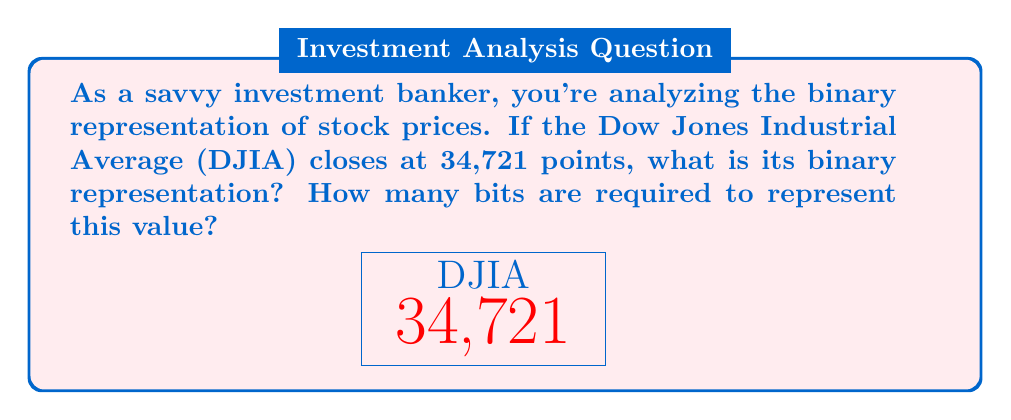Give your solution to this math problem. Let's approach this step-by-step:

1) To convert decimal to binary, we divide the number by 2 repeatedly and keep track of the remainders. The remainders in reverse order form the binary number.

   $34721 \div 2 = 17360$ remainder $1$
   $17360 \div 2 = 8680$  remainder $0$
   $8680 \div 2 = 4340$   remainder $0$
   $4340 \div 2 = 2170$   remainder $0$
   $2170 \div 2 = 1085$   remainder $0$
   $1085 \div 2 = 542$    remainder $1$
   $542 \div 2 = 271$     remainder $0$
   $271 \div 2 = 135$     remainder $1$
   $135 \div 2 = 67$      remainder $1$
   $67 \div 2 = 33$       remainder $1$
   $33 \div 2 = 16$       remainder $1$
   $16 \div 2 = 8$        remainder $0$
   $8 \div 2 = 4$         remainder $0$
   $4 \div 2 = 2$         remainder $0$
   $2 \div 2 = 1$         remainder $0$
   $1 \div 2 = 0$         remainder $1$

2) Reading the remainders from bottom to top, we get:
   
   $34721_{10} = 1000011110100001_2$

3) To count the bits, we simply count the digits in the binary representation:

   $1000011110100001_2$ has 16 bits.

Therefore, the DJIA closing value of 34,721 is represented as 1000011110100001 in binary, requiring 16 bits.
Answer: $1000011110100001_2$, 16 bits 